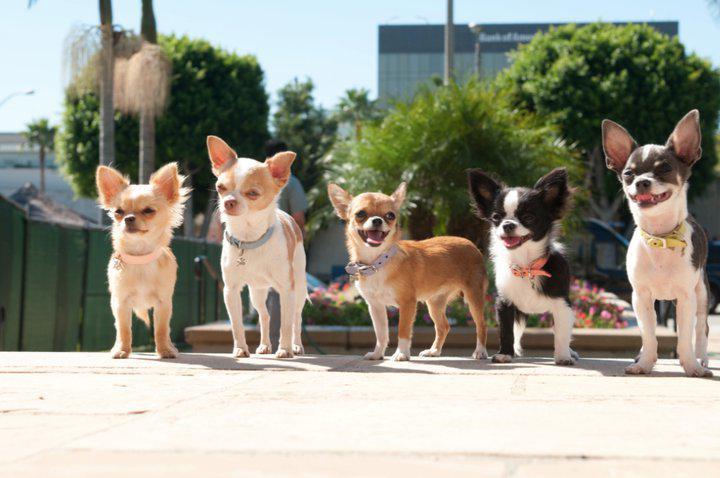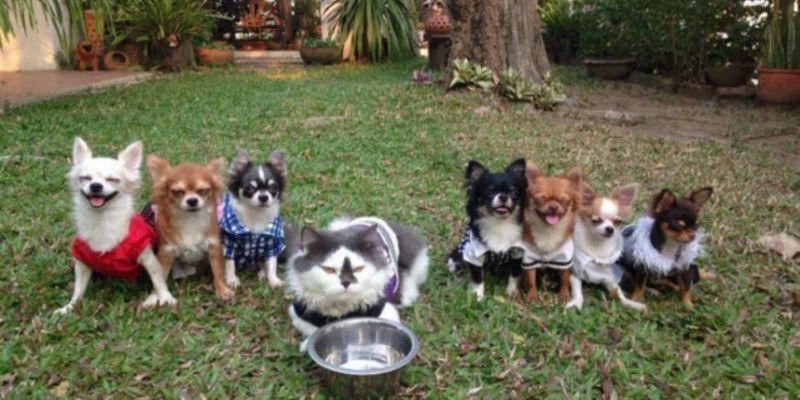The first image is the image on the left, the second image is the image on the right. Analyze the images presented: Is the assertion "There are five dogs in the left picture." valid? Answer yes or no. Yes. The first image is the image on the left, the second image is the image on the right. Given the left and right images, does the statement "A cat is in the middle of a horizontal row of dogs in one image." hold true? Answer yes or no. Yes. 